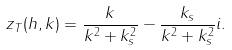<formula> <loc_0><loc_0><loc_500><loc_500>z _ { T } ( h , k ) = \frac { k } { k ^ { 2 } + k _ { s } ^ { 2 } } - \frac { k _ { s } } { k ^ { 2 } + k _ { s } ^ { 2 } } i .</formula> 